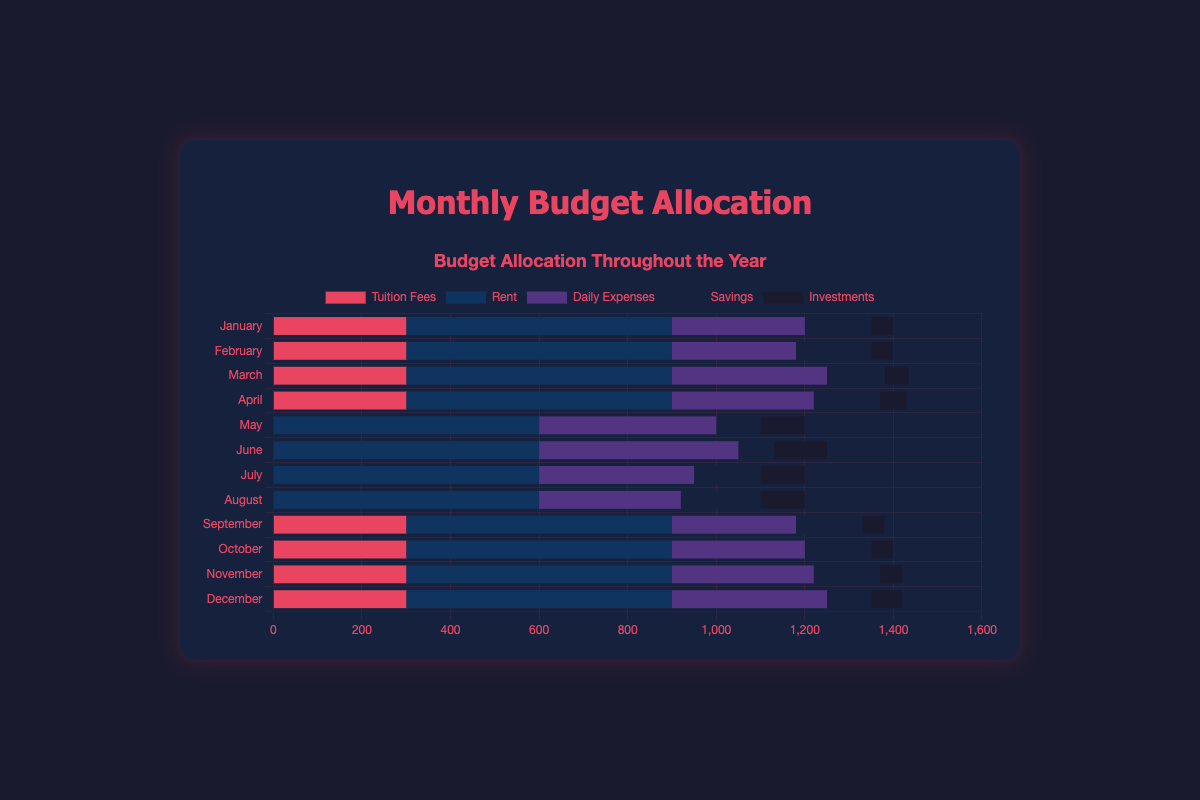What is the total amount allocated to rent for the entire year? Add the rent amounts for each month: 600 * 12 = 7200
Answer: 7200 Which month has the highest investment amount? The investment amounts are displayed on the chart for each month; June has the highest investment amount of 120
Answer: June What is the average amount spent on daily expenses per month? Sum the daily expenses for all months and divide by 12: (300 + 280 + 350 + 320 + 400 + 450 + 350 + 320 + 280 + 300 + 320 + 350) / 12 = 4040 / 12 = 336.67
Answer: 336.67 Is there any month where tuition fees, rent, and daily expenses together are less than 1000? Combine the tuition, rent, and daily expenses for each month. For example, January: 300 + 600 + 300 = 1200, etc. None of the months have a combined amount less than 1000
Answer: No How does the savings in April compare to the savings in June? The savings in April is 150, and the savings in June is 80, so savings in April is greater than in June
Answer: April is greater than June What is the month with the least daily expenses? Visual comparison shows February and September have the lowest daily expenses of 280 each
Answer: February and September Which expense category has the highest total allocation over the year? Sum each category for all months. Tuition fees: (300 * 8) = 2400, Rent: (600 * 12) = 7200, Daily expenses: 4040, Savings: 1760, Investments: 855. Rent has the highest total allocation
Answer: Rent What is the visual color representing investments? In the chart, investments are represented by a dark shade (near black)
Answer: Dark shade How much more is spent on rent than on savings in November? Rent in November is 600, and savings in November is 150. The difference is 600 - 150 = 450
Answer: 450 If you exclude tuition fees, what is the total budget for July? In July, sum all expenses but tuition fees: 600 + 350 + 150+ 100 = 1200
Answer: 1200 